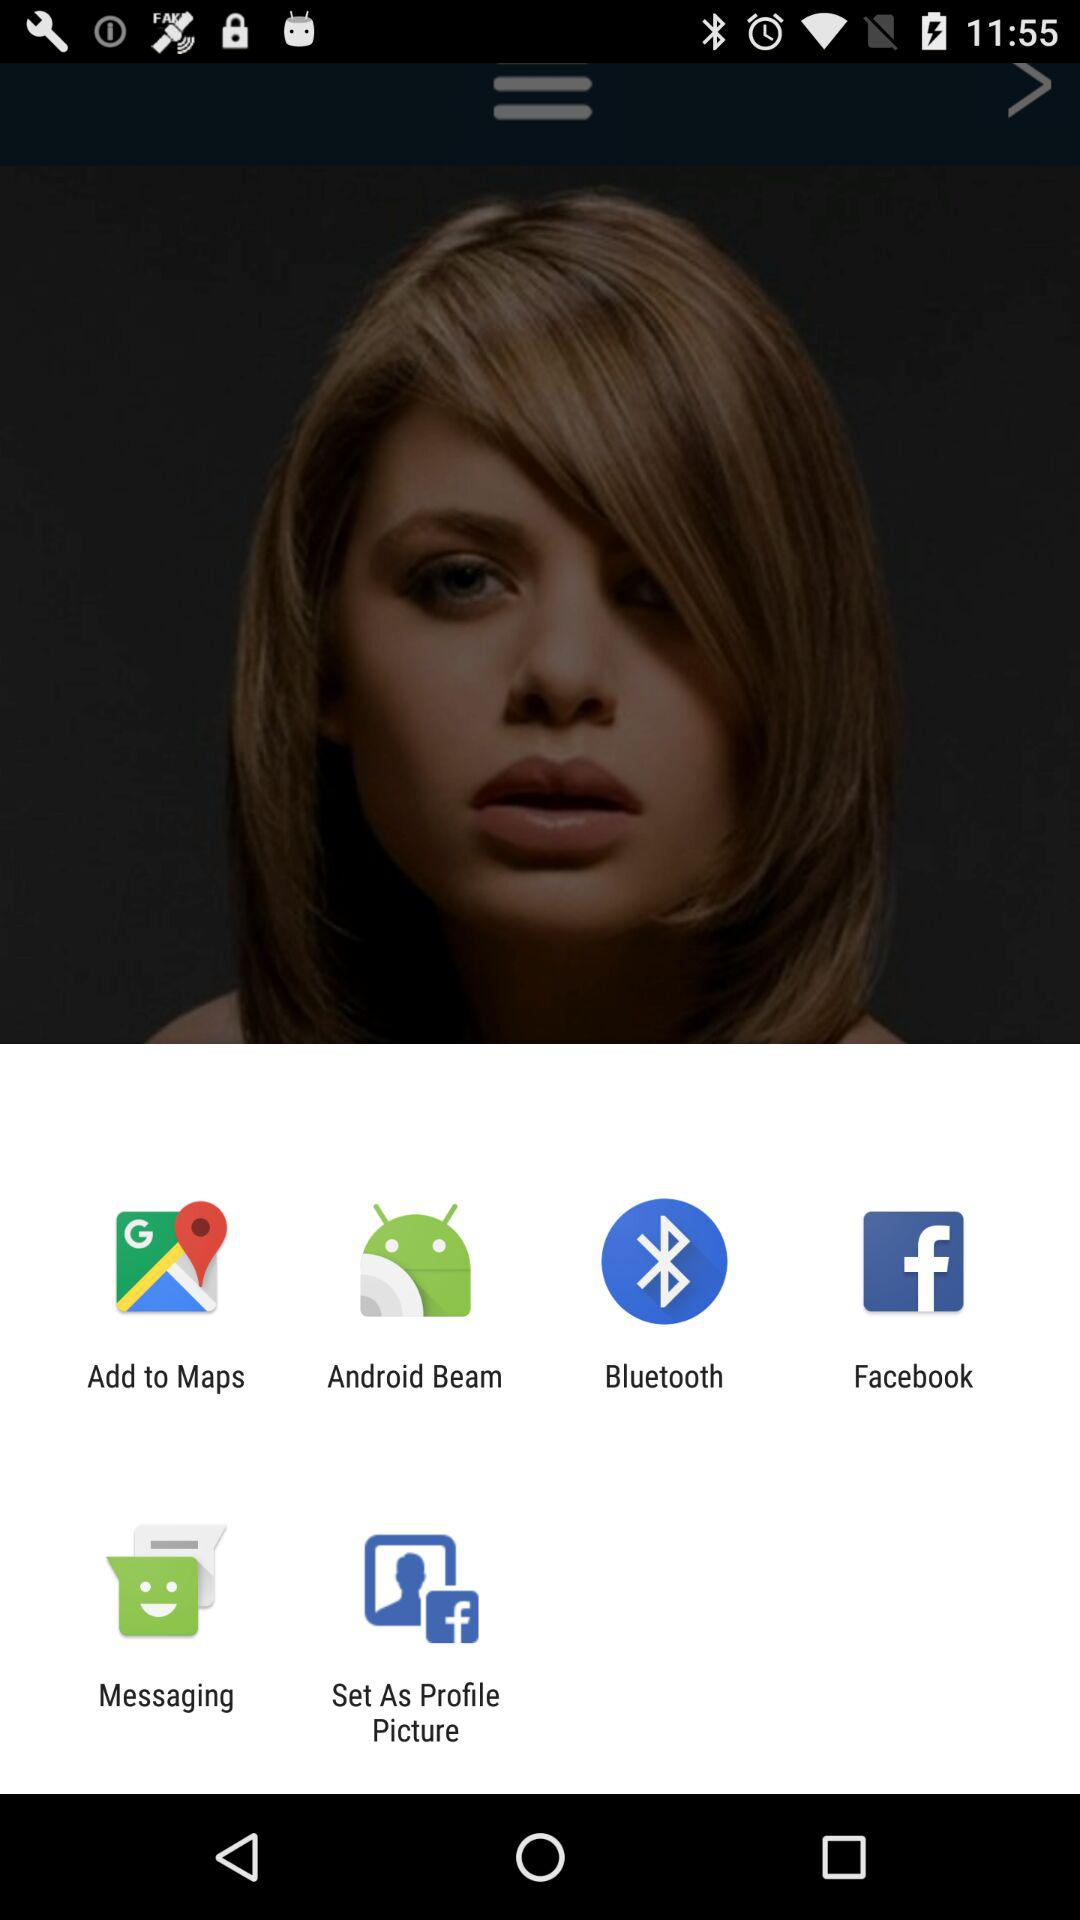Which applications are shown on the screen? The applications are "Android Beam", "Bluetooth", "Facebook" and "Messaging". 